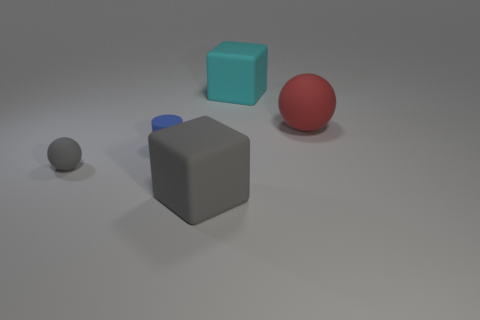Does the cylinder have the same color as the tiny ball?
Your answer should be compact. No. There is a big object that is in front of the gray object that is behind the large matte thing left of the large cyan cube; what is its material?
Provide a succinct answer. Rubber. How many objects are either large gray cubes or tiny brown matte balls?
Provide a short and direct response. 1. Is there anything else that has the same material as the big gray thing?
Ensure brevity in your answer.  Yes. What is the shape of the large gray object?
Offer a very short reply. Cube. What is the shape of the gray rubber thing that is to the left of the big rubber cube on the left side of the cyan rubber object?
Provide a succinct answer. Sphere. Do the large cube that is in front of the blue matte thing and the red sphere have the same material?
Make the answer very short. Yes. How many red things are large cubes or tiny rubber objects?
Provide a succinct answer. 0. Is there another tiny cylinder of the same color as the tiny cylinder?
Your response must be concise. No. Are there any other small things that have the same material as the blue object?
Offer a very short reply. Yes. 